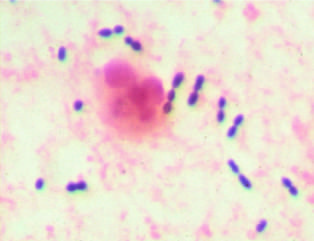re impaired remodeling of calcified cartilage in the epiphyses of the wrist evident?
Answer the question using a single word or phrase. No 